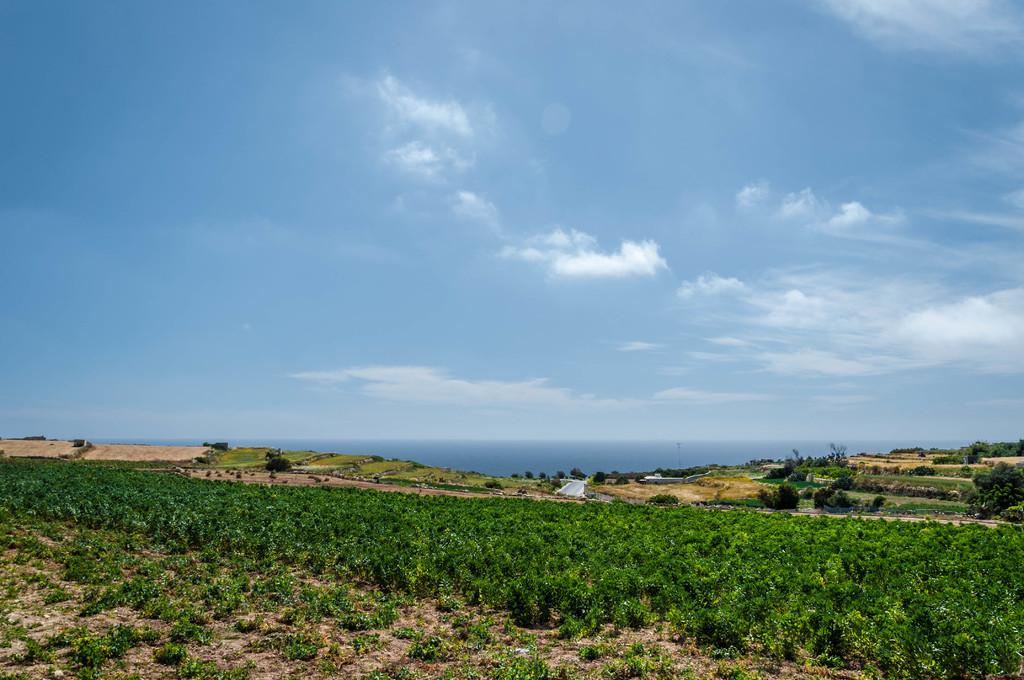What type of vegetation is in the front of the image? There are plants in the front of the image. What type of ground cover can be seen in the background of the image? There is grass in the background of the image. What other type of vegetation is in the background of the image? There are trees in the background of the image. What is visible in the sky in the background of the image? The sky is visible in the background of the image, and clouds are present. What type of knife is being used to cut the trees in the image? There is no knife present in the image, and no trees are being cut. What color is the vest worn by the grass in the image? There is no vest present in the image, and grass does not wear clothing. 